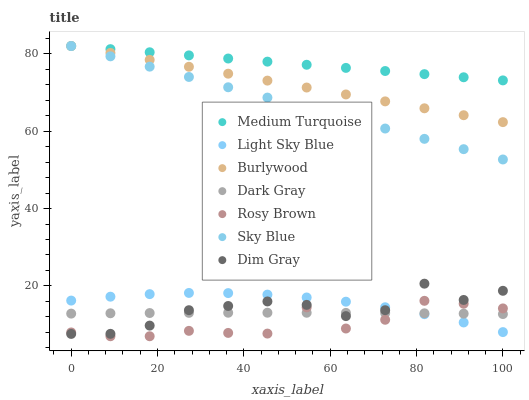Does Rosy Brown have the minimum area under the curve?
Answer yes or no. Yes. Does Medium Turquoise have the maximum area under the curve?
Answer yes or no. Yes. Does Burlywood have the minimum area under the curve?
Answer yes or no. No. Does Burlywood have the maximum area under the curve?
Answer yes or no. No. Is Medium Turquoise the smoothest?
Answer yes or no. Yes. Is Rosy Brown the roughest?
Answer yes or no. Yes. Is Burlywood the smoothest?
Answer yes or no. No. Is Burlywood the roughest?
Answer yes or no. No. Does Rosy Brown have the lowest value?
Answer yes or no. Yes. Does Burlywood have the lowest value?
Answer yes or no. No. Does Sky Blue have the highest value?
Answer yes or no. Yes. Does Rosy Brown have the highest value?
Answer yes or no. No. Is Dark Gray less than Burlywood?
Answer yes or no. Yes. Is Sky Blue greater than Dim Gray?
Answer yes or no. Yes. Does Dark Gray intersect Light Sky Blue?
Answer yes or no. Yes. Is Dark Gray less than Light Sky Blue?
Answer yes or no. No. Is Dark Gray greater than Light Sky Blue?
Answer yes or no. No. Does Dark Gray intersect Burlywood?
Answer yes or no. No. 